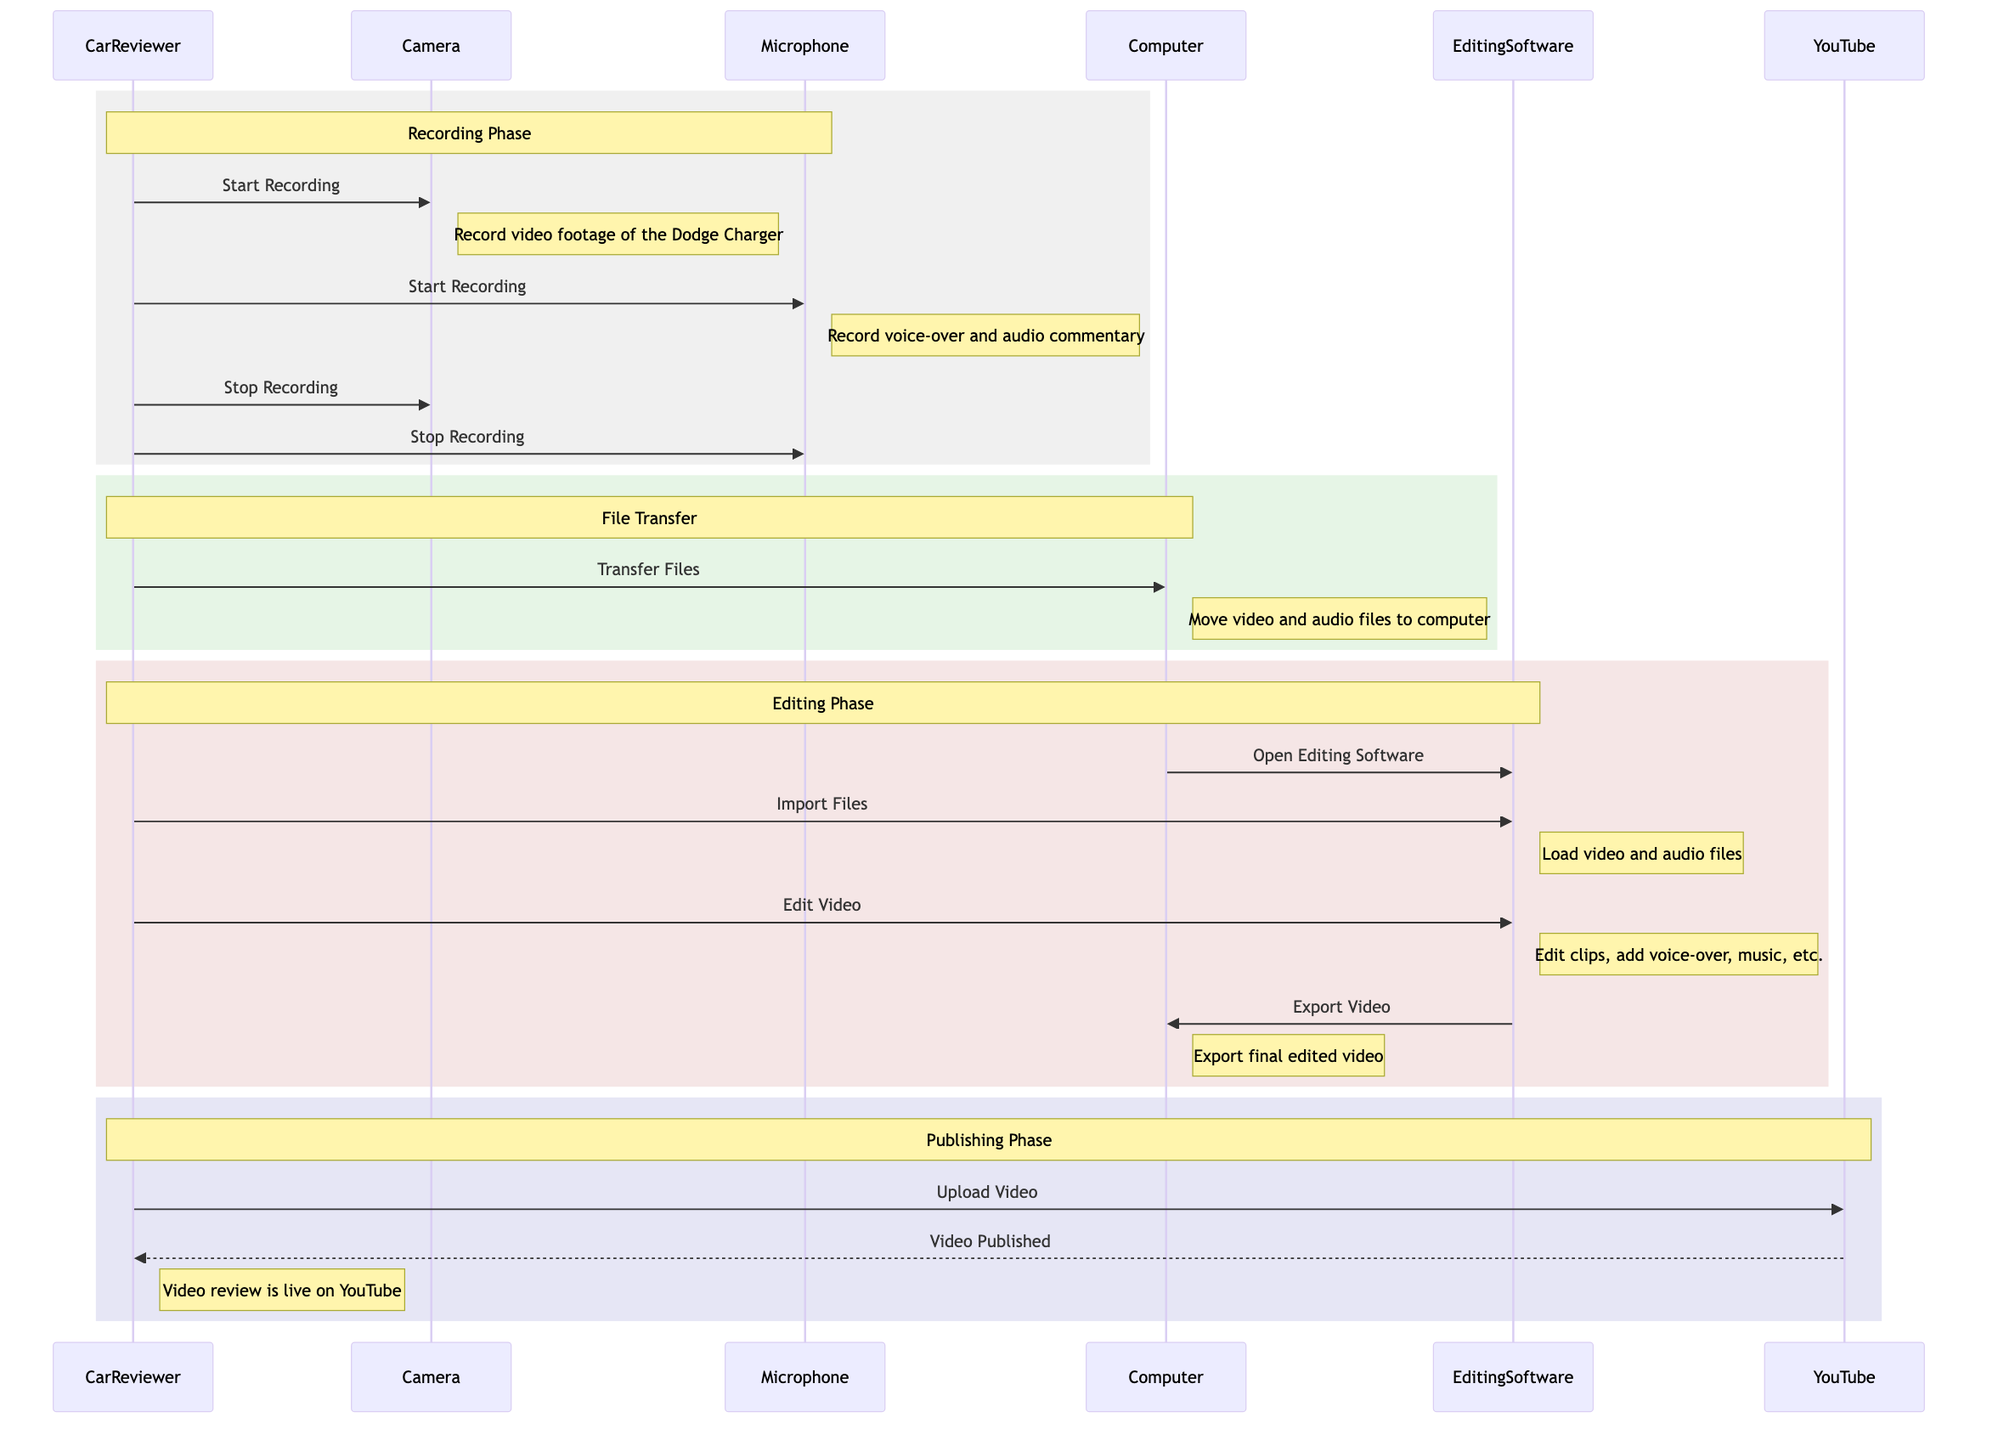What are the participants involved in the video review production? The diagram lists six participants: CarReviewer, Camera, Microphone, EditingSoftware, Computer, and YouTube. This information can be found in the "participants" section of the diagram.
Answer: CarReviewer, Camera, Microphone, EditingSoftware, Computer, YouTube How many messages does CarReviewer send in total? By counting the arrows originating from CarReviewer, there are five messages: two for starting recording, two for stopping recording, one for transferring files, one for importing files, and one for editing video, bringing the total to five.
Answer: Five What is the first action taken by CarReviewer? Looking at the timeline in the "Recording Phase," the first action taken by CarReviewer is to send the message "Start Recording" to the Camera. This action initiates the video recording process.
Answer: Start Recording What is the last action of CarReviewer in the sequence? The last action of CarReviewer in the sequence is "Upload Video" to YouTube. This concludes the workflow after editing and exporting the video.
Answer: Upload Video How many phases are there in the video review production process? The diagram defines four distinct phases: Recording Phase, File Transfer, Editing Phase, and Publishing Phase. Each phase is indicated by a rectangular area with notes describing the activities.
Answer: Four What happens after the "Export Video" message is sent? After the "Export Video" message is sent from EditingSoftware to Computer, the process continues with CarReviewer uploading the video to YouTube, which is the next message in the sequence.
Answer: Upload Video What type of software is used for editing? The EditingSoftware node is referenced in the diagram, implying that software such as Adobe Premiere Pro could be used based on common industry standards. This is inferred from the context provided in the messages and notes.
Answer: Adobe Premiere Pro What confirms that the video review is live on YouTube? The confirmation that the video review is live on YouTube is received through the message "Video Published" sent from YouTube to CarReviewer. This message signals the completion of the publishing process.
Answer: Video Published 